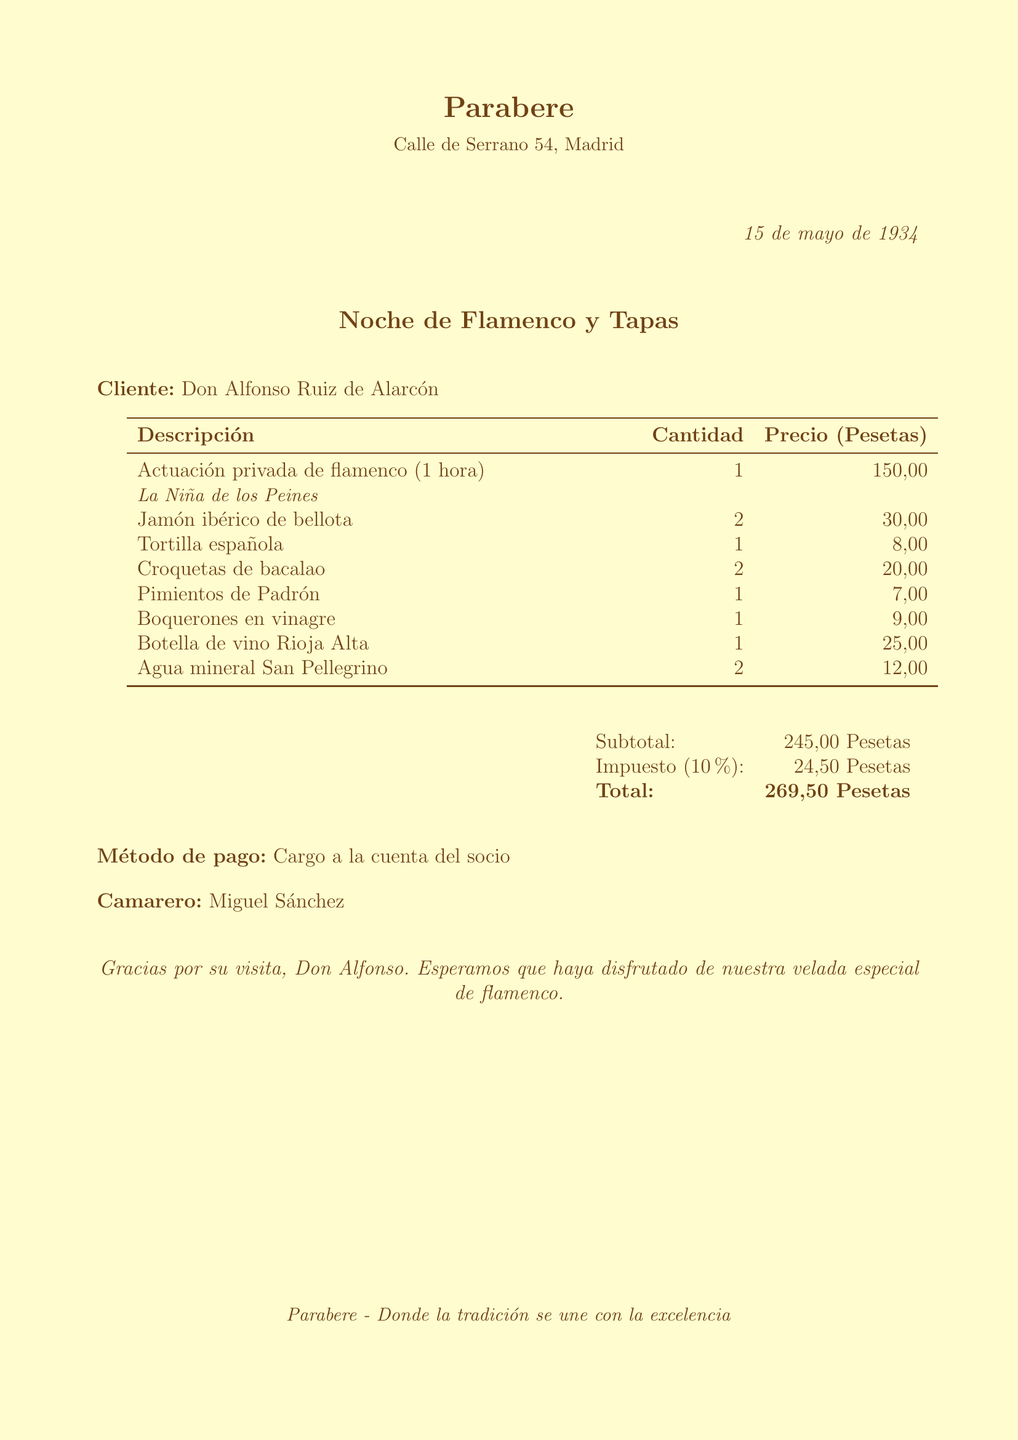what is the restaurant name? The restaurant name is prominently displayed at the top of the document.
Answer: Parabere who performed the flamenco act? The name of the performer is mentioned in the description of the flamenco act as a sub-item.
Answer: La Niña de los Peines what is the date of the event? The date is located in the upper right corner of the document.
Answer: 15 de mayo de 1934 what is the total amount charged? The total amount is calculated at the end of the receipt after the subtotal and tax.
Answer: 269,50 Pesetas how many tapas were ordered? This requires adding the quantities of all tapas items listed in the document.
Answer: 7 who served the meal? The name of the waiter is noted on the receipt.
Answer: Miguel Sánchez what item costs the most? The items are listed with their prices, and the highest price represents the most expensive item.
Answer: Actuación privada de flamenco (1 hora) what payment method was used? The payment method is specified toward the bottom of the receipt.
Answer: Cargo a la cuenta del socio 